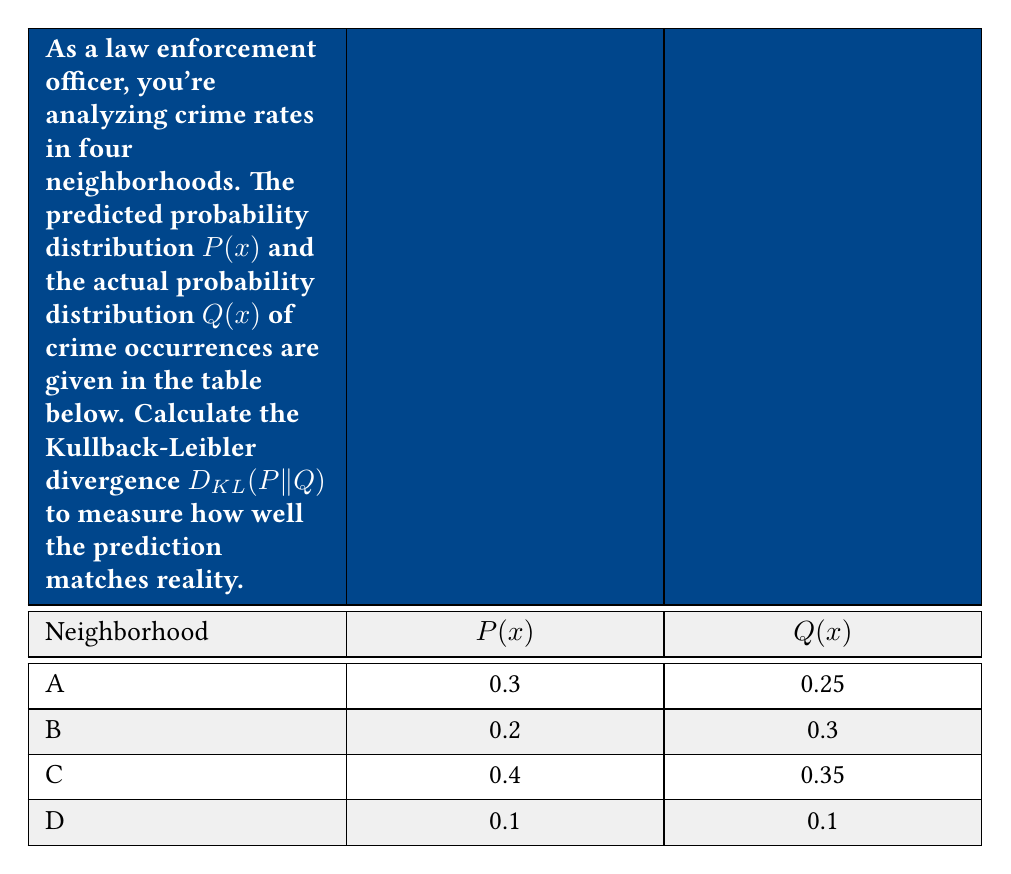Show me your answer to this math problem. To calculate the Kullback-Leibler divergence D_KL(P||Q), we use the formula:

$$D_{KL}(P||Q) = \sum_{x} P(x) \log \frac{P(x)}{Q(x)}$$

Let's calculate this step-by-step:

1) For Neighborhood A:
   $P(x) = 0.3$, $Q(x) = 0.25$
   $0.3 \log \frac{0.3}{0.25} = 0.3 \log 1.2 = 0.3 \cdot 0.0792 = 0.02376$

2) For Neighborhood B:
   $P(x) = 0.2$, $Q(x) = 0.3$
   $0.2 \log \frac{0.2}{0.3} = 0.2 \log 0.6667 = 0.2 \cdot (-0.1761) = -0.03522$

3) For Neighborhood C:
   $P(x) = 0.4$, $Q(x) = 0.35$
   $0.4 \log \frac{0.4}{0.35} = 0.4 \log 1.1429 = 0.4 \cdot 0.0580 = 0.0232$

4) For Neighborhood D:
   $P(x) = 0.1$, $Q(x) = 0.1$
   $0.1 \log \frac{0.1}{0.1} = 0.1 \log 1 = 0$

5) Sum up all the terms:
   $D_{KL}(P||Q) = 0.02376 + (-0.03522) + 0.0232 + 0 = 0.01174$

The Kullback-Leibler divergence is approximately 0.01174 nats.
Answer: $D_{KL}(P||Q) \approx 0.01174$ nats 